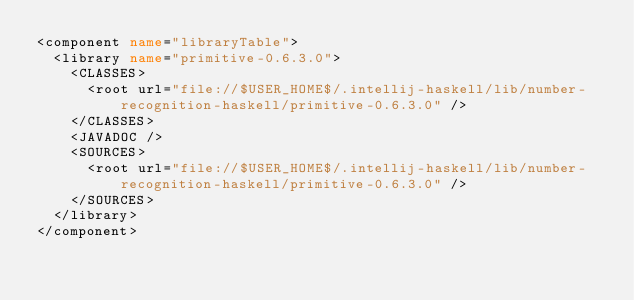Convert code to text. <code><loc_0><loc_0><loc_500><loc_500><_XML_><component name="libraryTable">
  <library name="primitive-0.6.3.0">
    <CLASSES>
      <root url="file://$USER_HOME$/.intellij-haskell/lib/number-recognition-haskell/primitive-0.6.3.0" />
    </CLASSES>
    <JAVADOC />
    <SOURCES>
      <root url="file://$USER_HOME$/.intellij-haskell/lib/number-recognition-haskell/primitive-0.6.3.0" />
    </SOURCES>
  </library>
</component></code> 